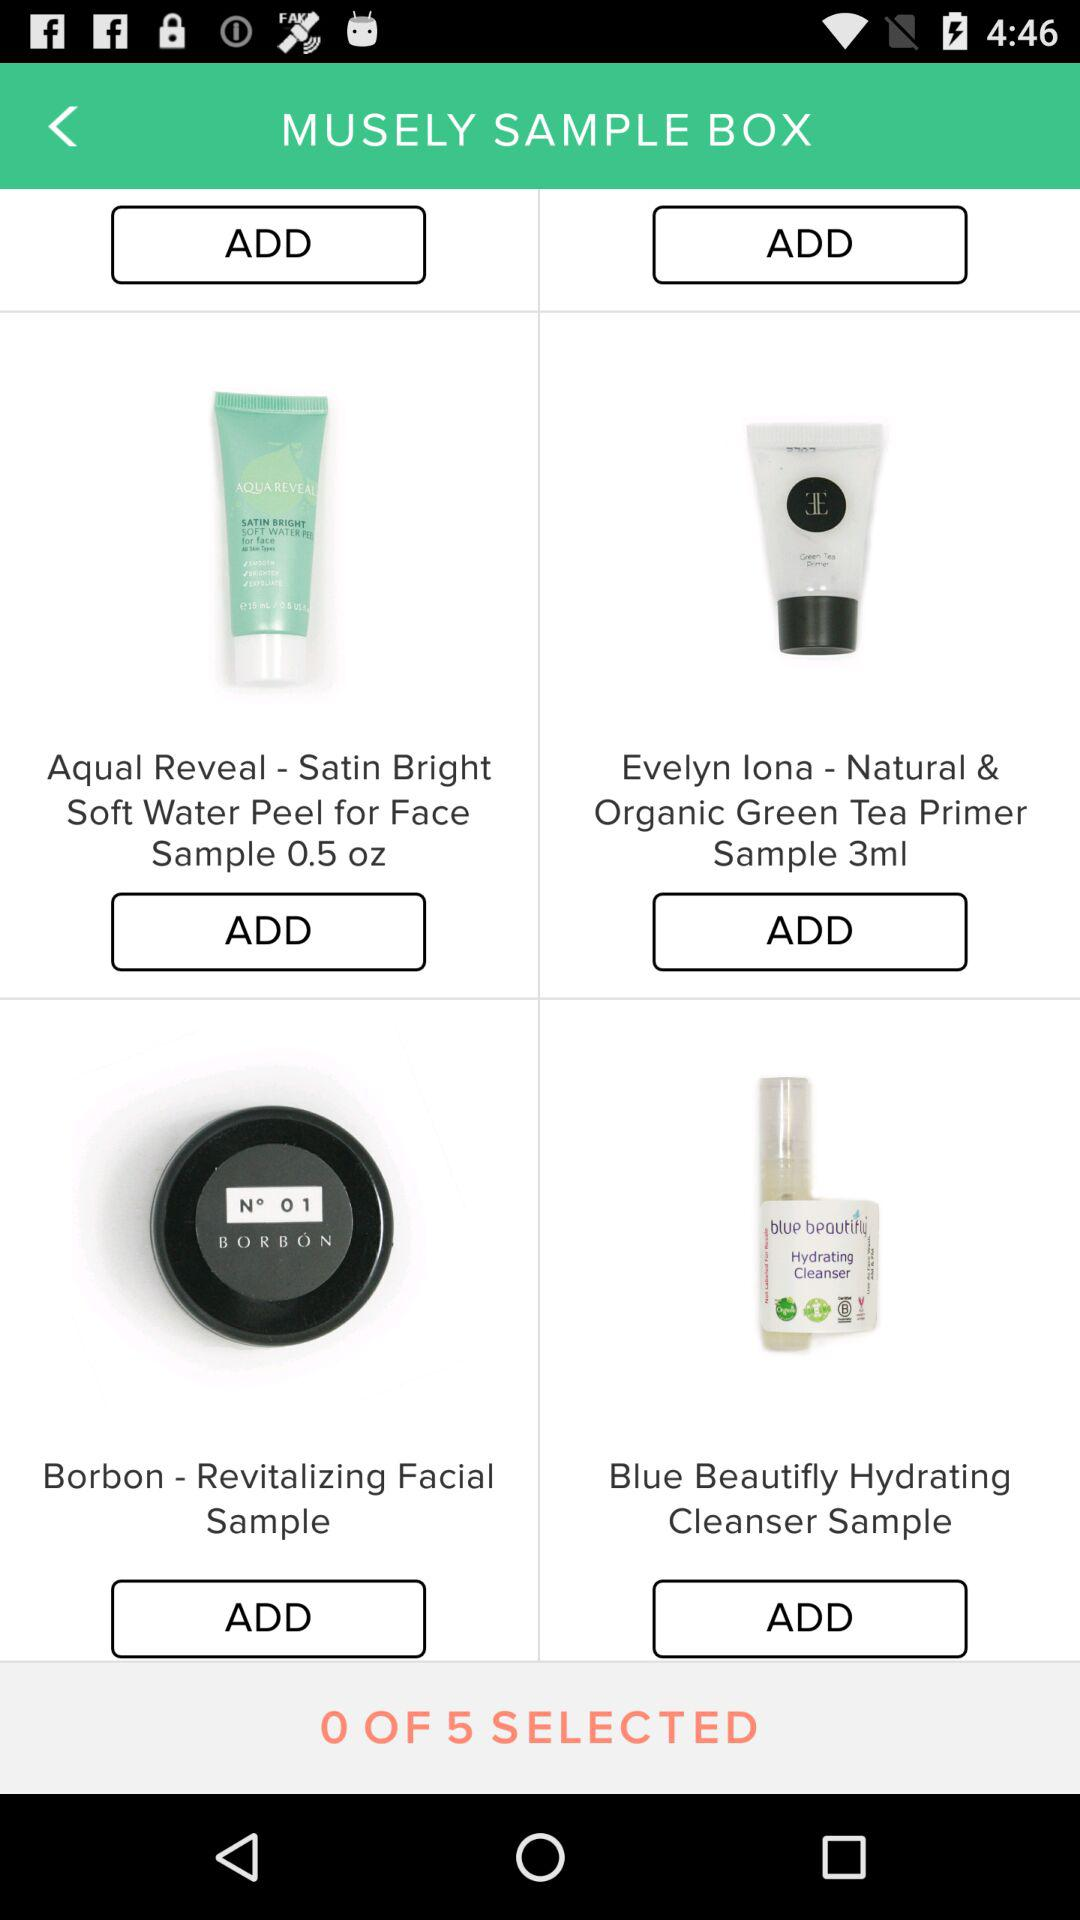How many items in total are to be selected? The total number of items that are to be selected is 5. 